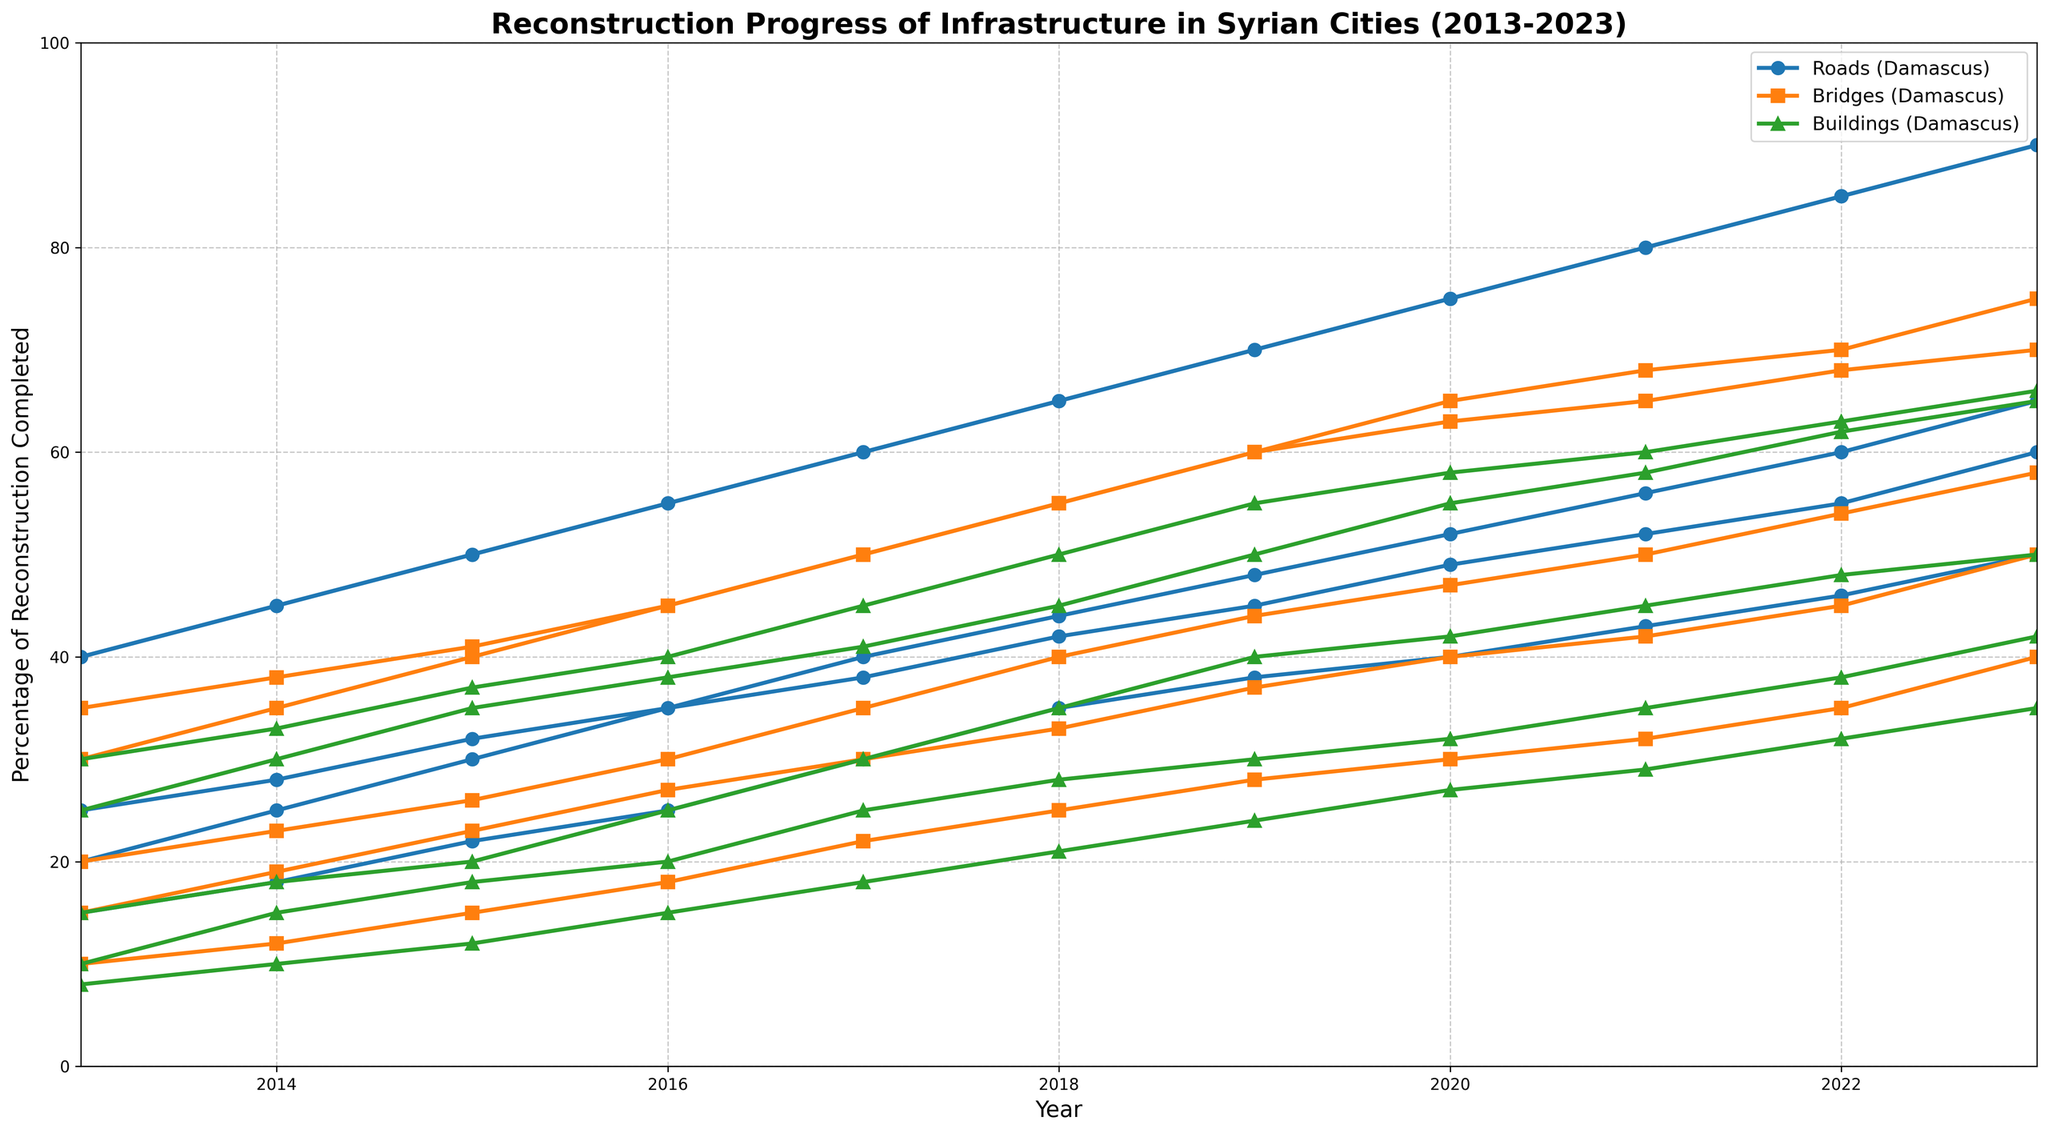What type of infrastructure sees the highest reconstruction progress in Damascus by 2023? Refer to the highest point on the corresponding colored line for Damascus in 2023. Roads are represented by blue, Bridges by orange, and Buildings by green. The highest value for Damascus in 2023 is for Roads.
Answer: Roads Comparing Aleppo and Homs, which city shows greater reconstruction progress for Bridges in 2019? Look at the data points for Bridges (orange line) for Aleppo and Homs in 2019. Aleppo has a value of 44, while Homs has a value of 37. Therefore, Aleppo shows greater progress.
Answer: Aleppo What is the percentage difference in reconstruction progress of Buildings between Damascus and Lattakia in 2020? In 2020, the reconstruction progress of Buildings is 55% in Damascus and 58% in Lattakia. The difference is 58 - 55 = 3%.
Answer: 3% Which type of infrastructure in Hama showed the least progress in 2015, and what was the percentage? In 2015, compare the values of Roads, Bridges, and Buildings in Hama. Roads: 22%, Bridges: 15%, Buildings: 12%. The least progress was in Buildings at 12%.
Answer: Buildings, 12% How does the progress of Roads in Aleppo in 2013 compare to that in Hama in 2016? Look at the blue line for Aleppo in 2013, which is at 25%, and for Hama in 2016, which is at 25%. The values are equal.
Answer: Equal By how much did the reconstruction progress for Bridges in Lattakia increase from 2018 to 2023? In 2018, the Bridges reconstruction in Lattakia was at 55%, and in 2023, it was 70%. The increase is 70 - 55 = 15%.
Answer: 15% What is the average reconstruction progress of Roads in Homs over the entire period from 2013 to 2023? Sum the progress values for Roads in Homs from 2013 to 2023: (20 + 25 + 30 + 35 + 38 + 42 + 45 + 49 + 52 + 55 + 60). The total is 451. There are 11 years, so the average is 451 / 11 = 41%.
Answer: 41% Did any type of infrastructure in Hama reach over 50% in reconstruction progress by 2022? Check the data points for Roads, Bridges, and Buildings for Hama in 2022. Roads reached 46%, Bridges 35%, and Buildings 32%. None reached over 50%.
Answer: No Which city showed the fastest growth in Roads reconstruction between 2020 and 2023? Calculate the difference in values for each city between 2020 and 2023 for Roads. Damascus: 90 - 75 = 15, Aleppo: 65 - 52 = 13, Homs: 60 - 49 = 11, Hama: 50 - 40 = 10, Lattakia: 90 - 75 = 15. Both Damascus and Lattakia had the highest increase of 15%.
Answer: Damascus and Lattakia 